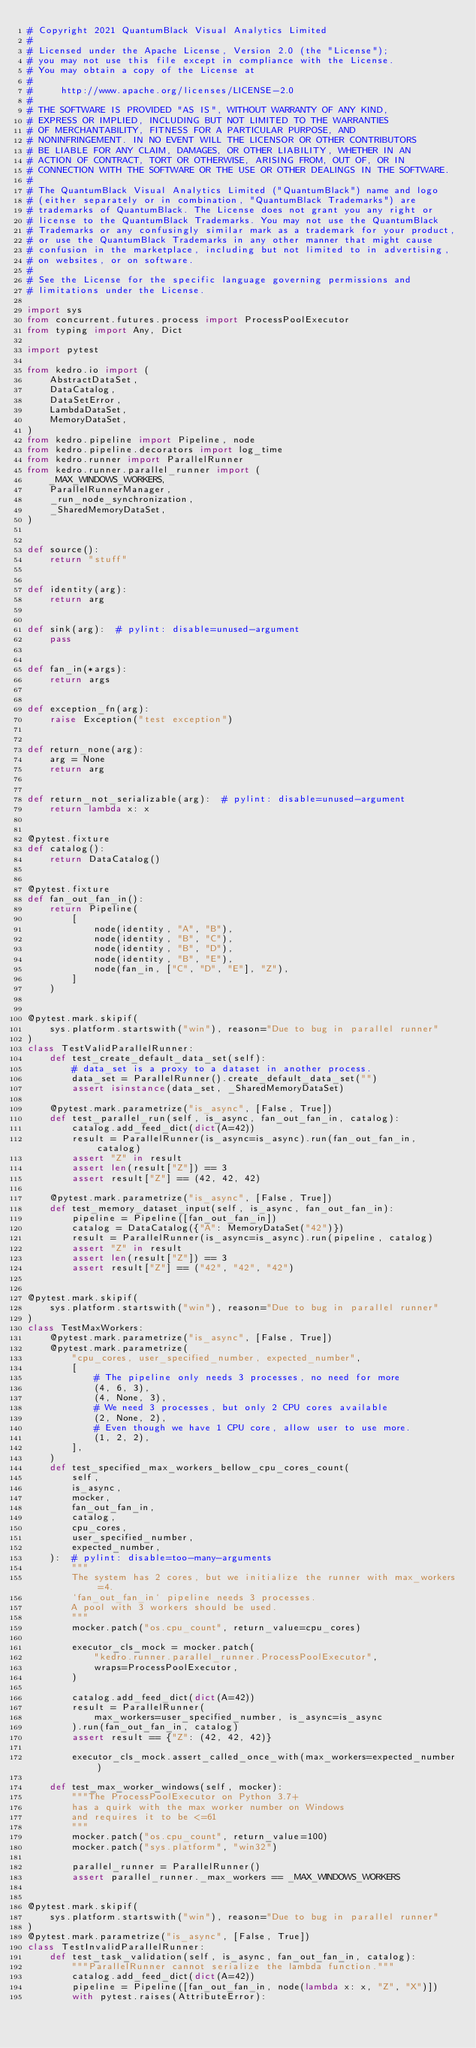<code> <loc_0><loc_0><loc_500><loc_500><_Python_># Copyright 2021 QuantumBlack Visual Analytics Limited
#
# Licensed under the Apache License, Version 2.0 (the "License");
# you may not use this file except in compliance with the License.
# You may obtain a copy of the License at
#
#     http://www.apache.org/licenses/LICENSE-2.0
#
# THE SOFTWARE IS PROVIDED "AS IS", WITHOUT WARRANTY OF ANY KIND,
# EXPRESS OR IMPLIED, INCLUDING BUT NOT LIMITED TO THE WARRANTIES
# OF MERCHANTABILITY, FITNESS FOR A PARTICULAR PURPOSE, AND
# NONINFRINGEMENT. IN NO EVENT WILL THE LICENSOR OR OTHER CONTRIBUTORS
# BE LIABLE FOR ANY CLAIM, DAMAGES, OR OTHER LIABILITY, WHETHER IN AN
# ACTION OF CONTRACT, TORT OR OTHERWISE, ARISING FROM, OUT OF, OR IN
# CONNECTION WITH THE SOFTWARE OR THE USE OR OTHER DEALINGS IN THE SOFTWARE.
#
# The QuantumBlack Visual Analytics Limited ("QuantumBlack") name and logo
# (either separately or in combination, "QuantumBlack Trademarks") are
# trademarks of QuantumBlack. The License does not grant you any right or
# license to the QuantumBlack Trademarks. You may not use the QuantumBlack
# Trademarks or any confusingly similar mark as a trademark for your product,
# or use the QuantumBlack Trademarks in any other manner that might cause
# confusion in the marketplace, including but not limited to in advertising,
# on websites, or on software.
#
# See the License for the specific language governing permissions and
# limitations under the License.

import sys
from concurrent.futures.process import ProcessPoolExecutor
from typing import Any, Dict

import pytest

from kedro.io import (
    AbstractDataSet,
    DataCatalog,
    DataSetError,
    LambdaDataSet,
    MemoryDataSet,
)
from kedro.pipeline import Pipeline, node
from kedro.pipeline.decorators import log_time
from kedro.runner import ParallelRunner
from kedro.runner.parallel_runner import (
    _MAX_WINDOWS_WORKERS,
    ParallelRunnerManager,
    _run_node_synchronization,
    _SharedMemoryDataSet,
)


def source():
    return "stuff"


def identity(arg):
    return arg


def sink(arg):  # pylint: disable=unused-argument
    pass


def fan_in(*args):
    return args


def exception_fn(arg):
    raise Exception("test exception")


def return_none(arg):
    arg = None
    return arg


def return_not_serializable(arg):  # pylint: disable=unused-argument
    return lambda x: x


@pytest.fixture
def catalog():
    return DataCatalog()


@pytest.fixture
def fan_out_fan_in():
    return Pipeline(
        [
            node(identity, "A", "B"),
            node(identity, "B", "C"),
            node(identity, "B", "D"),
            node(identity, "B", "E"),
            node(fan_in, ["C", "D", "E"], "Z"),
        ]
    )


@pytest.mark.skipif(
    sys.platform.startswith("win"), reason="Due to bug in parallel runner"
)
class TestValidParallelRunner:
    def test_create_default_data_set(self):
        # data_set is a proxy to a dataset in another process.
        data_set = ParallelRunner().create_default_data_set("")
        assert isinstance(data_set, _SharedMemoryDataSet)

    @pytest.mark.parametrize("is_async", [False, True])
    def test_parallel_run(self, is_async, fan_out_fan_in, catalog):
        catalog.add_feed_dict(dict(A=42))
        result = ParallelRunner(is_async=is_async).run(fan_out_fan_in, catalog)
        assert "Z" in result
        assert len(result["Z"]) == 3
        assert result["Z"] == (42, 42, 42)

    @pytest.mark.parametrize("is_async", [False, True])
    def test_memory_dataset_input(self, is_async, fan_out_fan_in):
        pipeline = Pipeline([fan_out_fan_in])
        catalog = DataCatalog({"A": MemoryDataSet("42")})
        result = ParallelRunner(is_async=is_async).run(pipeline, catalog)
        assert "Z" in result
        assert len(result["Z"]) == 3
        assert result["Z"] == ("42", "42", "42")


@pytest.mark.skipif(
    sys.platform.startswith("win"), reason="Due to bug in parallel runner"
)
class TestMaxWorkers:
    @pytest.mark.parametrize("is_async", [False, True])
    @pytest.mark.parametrize(
        "cpu_cores, user_specified_number, expected_number",
        [
            # The pipeline only needs 3 processes, no need for more
            (4, 6, 3),
            (4, None, 3),
            # We need 3 processes, but only 2 CPU cores available
            (2, None, 2),
            # Even though we have 1 CPU core, allow user to use more.
            (1, 2, 2),
        ],
    )
    def test_specified_max_workers_bellow_cpu_cores_count(
        self,
        is_async,
        mocker,
        fan_out_fan_in,
        catalog,
        cpu_cores,
        user_specified_number,
        expected_number,
    ):  # pylint: disable=too-many-arguments
        """
        The system has 2 cores, but we initialize the runner with max_workers=4.
        `fan_out_fan_in` pipeline needs 3 processes.
        A pool with 3 workers should be used.
        """
        mocker.patch("os.cpu_count", return_value=cpu_cores)

        executor_cls_mock = mocker.patch(
            "kedro.runner.parallel_runner.ProcessPoolExecutor",
            wraps=ProcessPoolExecutor,
        )

        catalog.add_feed_dict(dict(A=42))
        result = ParallelRunner(
            max_workers=user_specified_number, is_async=is_async
        ).run(fan_out_fan_in, catalog)
        assert result == {"Z": (42, 42, 42)}

        executor_cls_mock.assert_called_once_with(max_workers=expected_number)

    def test_max_worker_windows(self, mocker):
        """The ProcessPoolExecutor on Python 3.7+
        has a quirk with the max worker number on Windows
        and requires it to be <=61
        """
        mocker.patch("os.cpu_count", return_value=100)
        mocker.patch("sys.platform", "win32")

        parallel_runner = ParallelRunner()
        assert parallel_runner._max_workers == _MAX_WINDOWS_WORKERS


@pytest.mark.skipif(
    sys.platform.startswith("win"), reason="Due to bug in parallel runner"
)
@pytest.mark.parametrize("is_async", [False, True])
class TestInvalidParallelRunner:
    def test_task_validation(self, is_async, fan_out_fan_in, catalog):
        """ParallelRunner cannot serialize the lambda function."""
        catalog.add_feed_dict(dict(A=42))
        pipeline = Pipeline([fan_out_fan_in, node(lambda x: x, "Z", "X")])
        with pytest.raises(AttributeError):</code> 